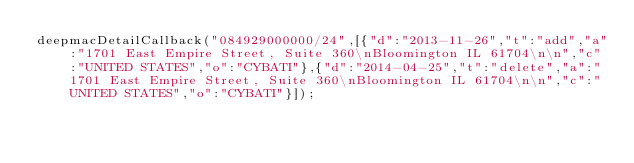Convert code to text. <code><loc_0><loc_0><loc_500><loc_500><_JavaScript_>deepmacDetailCallback("084929000000/24",[{"d":"2013-11-26","t":"add","a":"1701 East Empire Street, Suite 360\nBloomington IL 61704\n\n","c":"UNITED STATES","o":"CYBATI"},{"d":"2014-04-25","t":"delete","a":"1701 East Empire Street, Suite 360\nBloomington IL 61704\n\n","c":"UNITED STATES","o":"CYBATI"}]);
</code> 